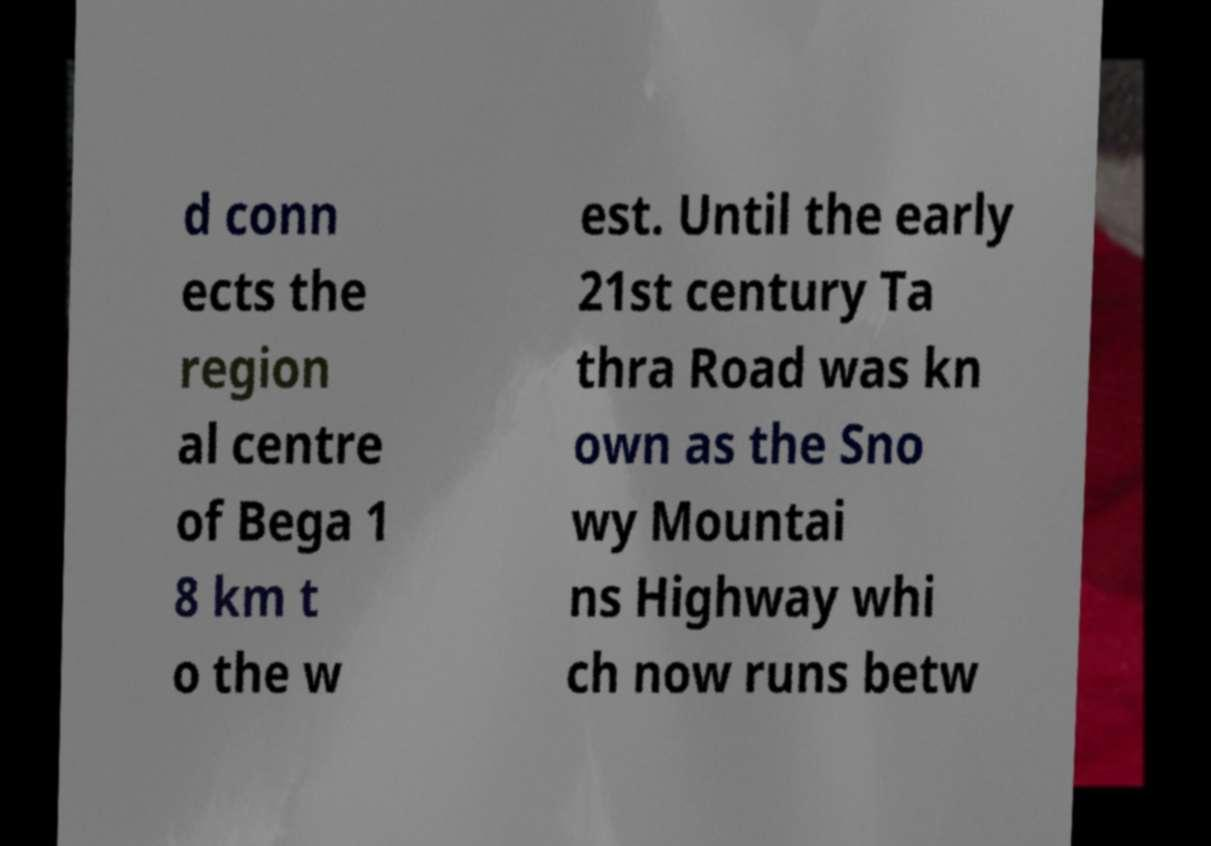There's text embedded in this image that I need extracted. Can you transcribe it verbatim? d conn ects the region al centre of Bega 1 8 km t o the w est. Until the early 21st century Ta thra Road was kn own as the Sno wy Mountai ns Highway whi ch now runs betw 